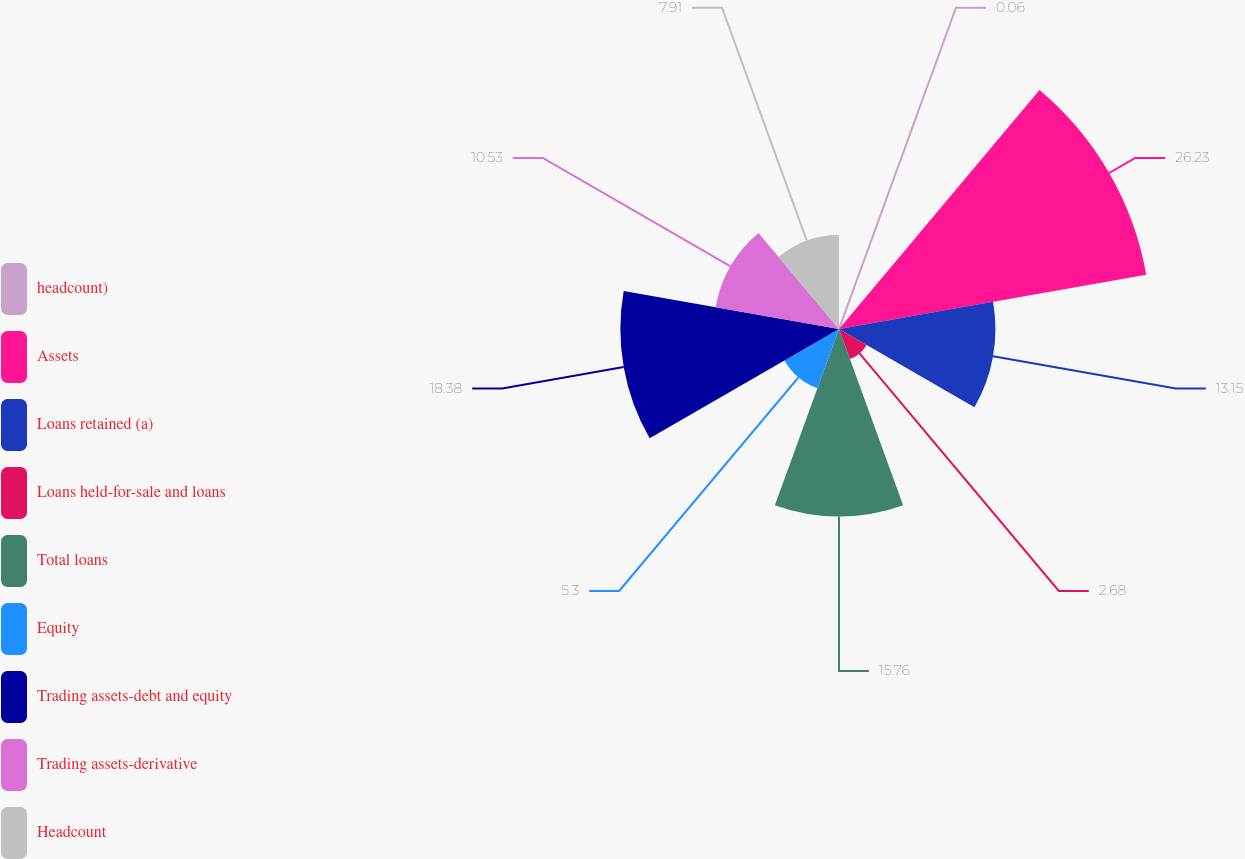<chart> <loc_0><loc_0><loc_500><loc_500><pie_chart><fcel>headcount)<fcel>Assets<fcel>Loans retained (a)<fcel>Loans held-for-sale and loans<fcel>Total loans<fcel>Equity<fcel>Trading assets-debt and equity<fcel>Trading assets-derivative<fcel>Headcount<nl><fcel>0.06%<fcel>26.23%<fcel>13.15%<fcel>2.68%<fcel>15.76%<fcel>5.3%<fcel>18.38%<fcel>10.53%<fcel>7.91%<nl></chart> 